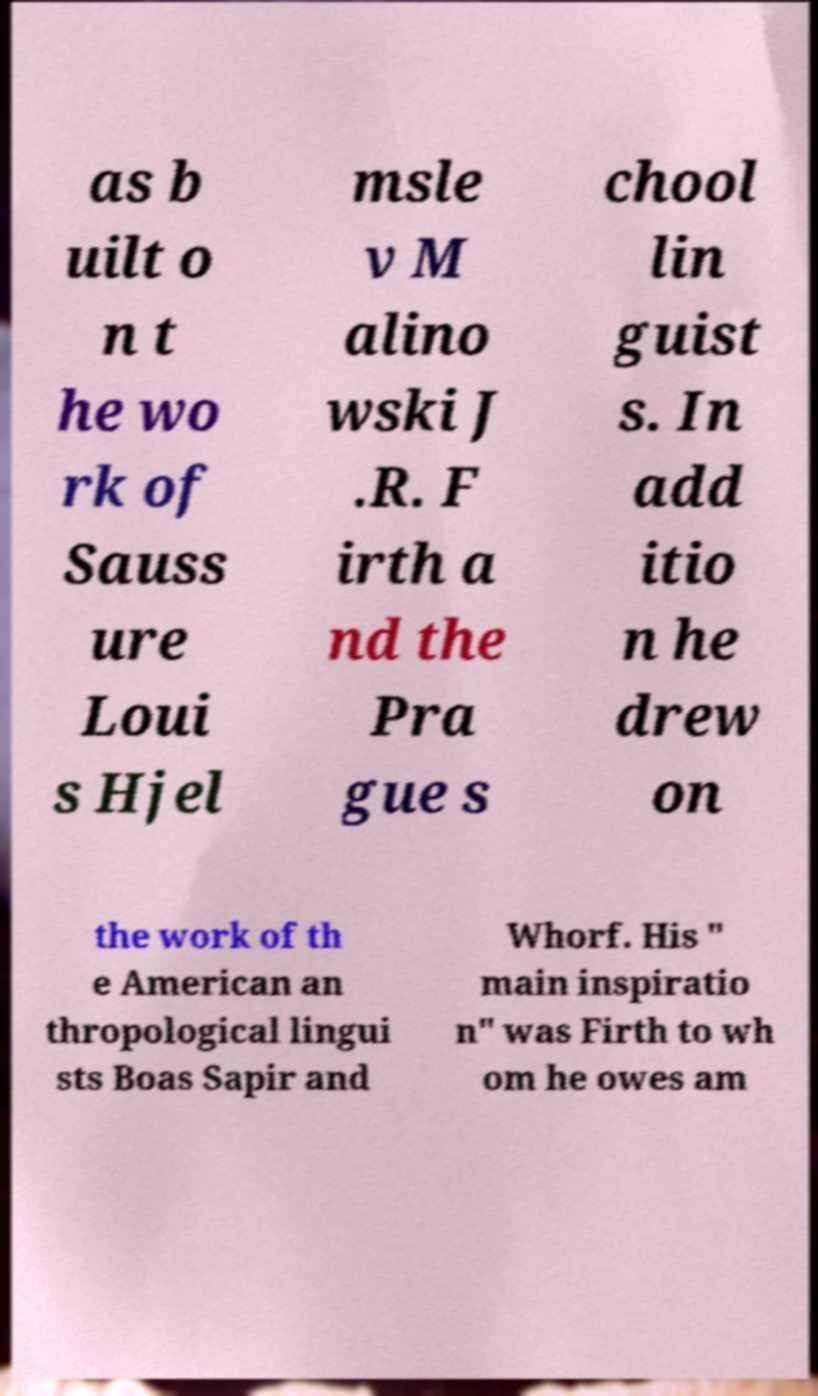For documentation purposes, I need the text within this image transcribed. Could you provide that? as b uilt o n t he wo rk of Sauss ure Loui s Hjel msle v M alino wski J .R. F irth a nd the Pra gue s chool lin guist s. In add itio n he drew on the work of th e American an thropological lingui sts Boas Sapir and Whorf. His " main inspiratio n" was Firth to wh om he owes am 